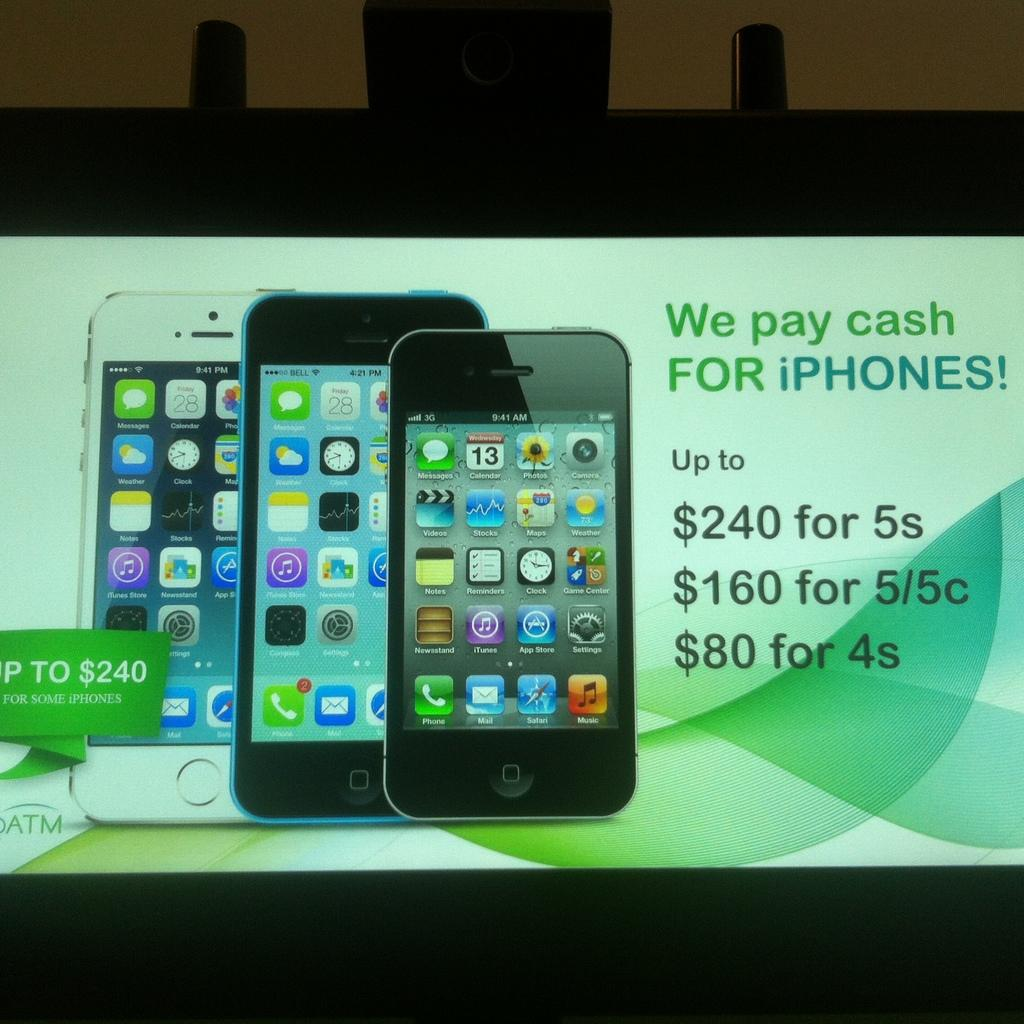What type of content is featured in the image? The image is an advertisement. What specific product is being advertised? The advertisement features images of mobiles. Is there any text present in the image? Yes, there is text in the advertisement. What can be seen in the background of the image? There is a wall in the background of the image. How many sons are visible in the image? There are no sons present in the image; it is an advertisement for mobiles. What is the distance between the office and the wall in the image? There is no office present in the image, and therefore no distance can be measured between it and the wall. 